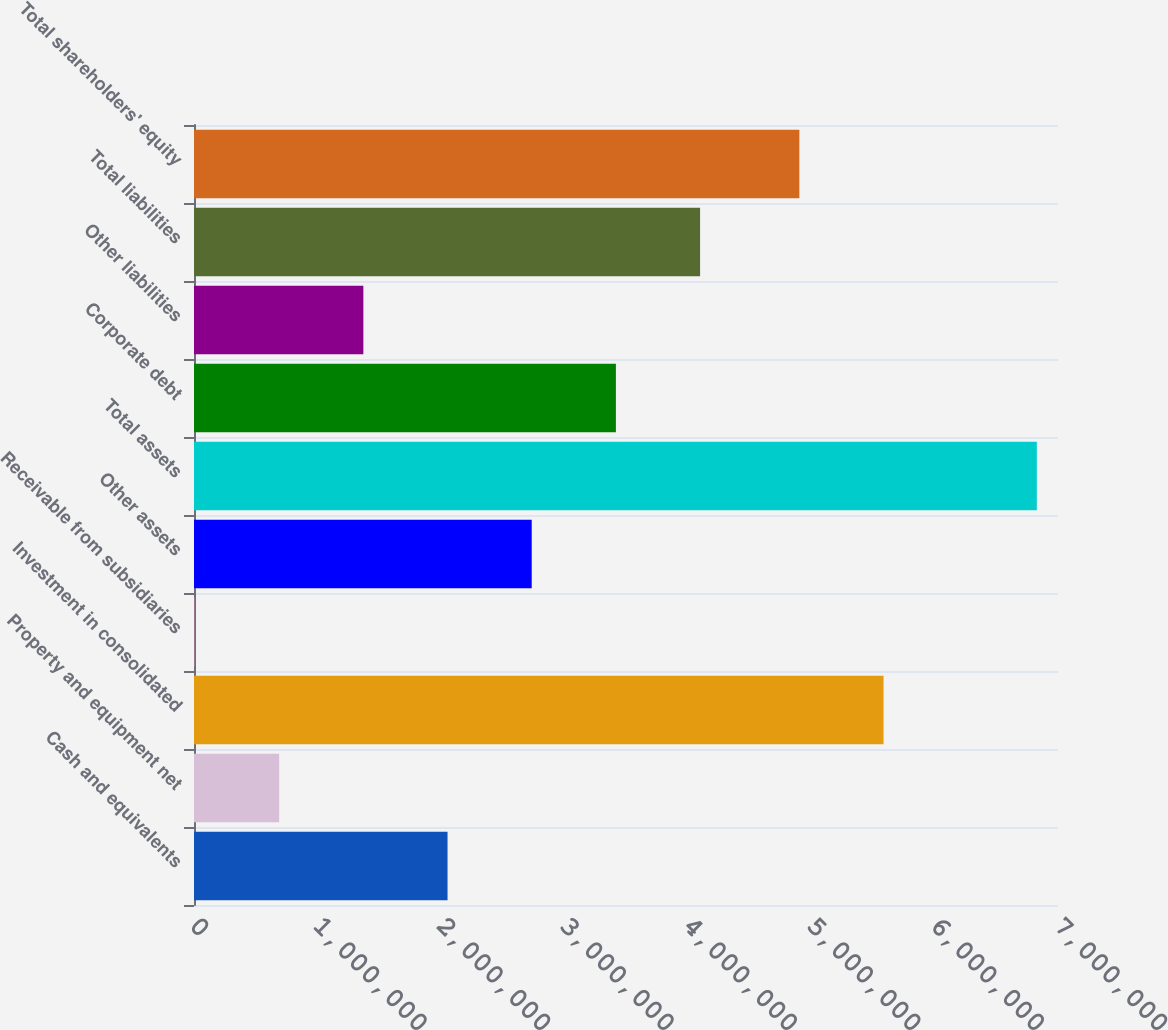<chart> <loc_0><loc_0><loc_500><loc_500><bar_chart><fcel>Cash and equivalents<fcel>Property and equipment net<fcel>Investment in consolidated<fcel>Receivable from subsidiaries<fcel>Other assets<fcel>Total assets<fcel>Corporate debt<fcel>Other liabilities<fcel>Total liabilities<fcel>Total shareholders' equity<nl><fcel>2.05412e+06<fcel>690030<fcel>5.58652e+06<fcel>7984<fcel>2.73617e+06<fcel>6.82845e+06<fcel>3.41822e+06<fcel>1.37208e+06<fcel>4.10026e+06<fcel>4.90447e+06<nl></chart> 